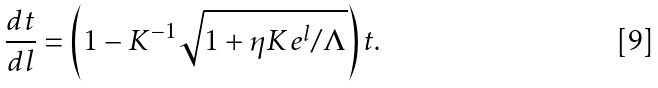Convert formula to latex. <formula><loc_0><loc_0><loc_500><loc_500>\frac { d t } { d l } = \left ( 1 - K ^ { - 1 } { \sqrt { 1 + \eta K e ^ { l } / \Lambda } } \right ) t .</formula> 